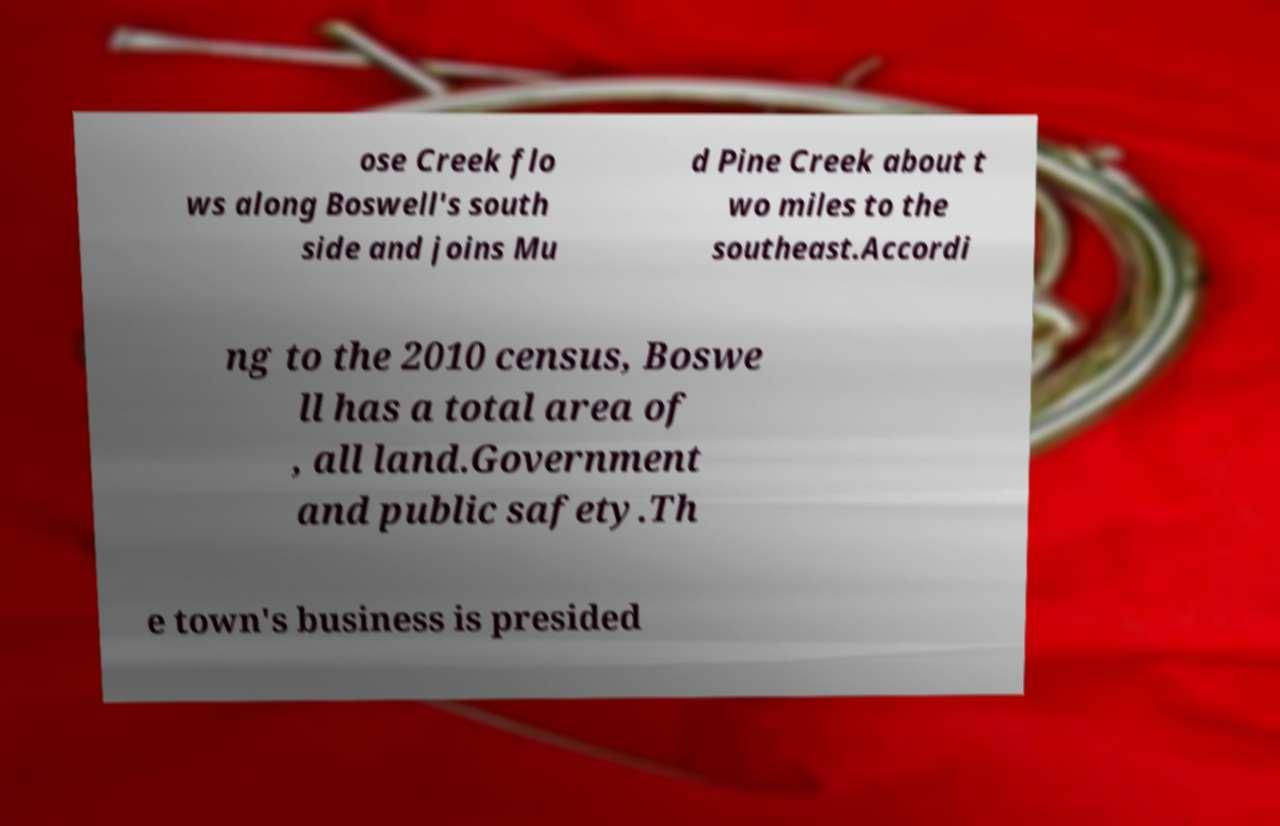What messages or text are displayed in this image? I need them in a readable, typed format. ose Creek flo ws along Boswell's south side and joins Mu d Pine Creek about t wo miles to the southeast.Accordi ng to the 2010 census, Boswe ll has a total area of , all land.Government and public safety.Th e town's business is presided 